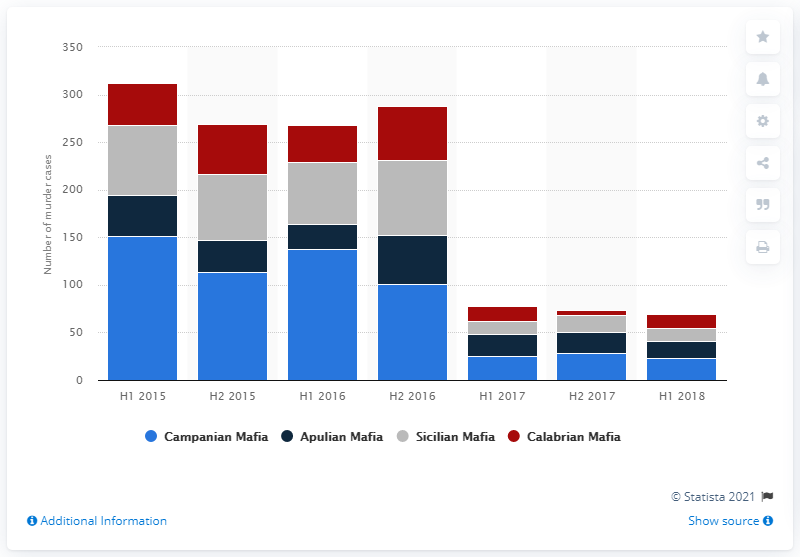Specify some key components in this picture. There were 28 murder cases committed by the Campanian Mafia in the second half of 2017. 